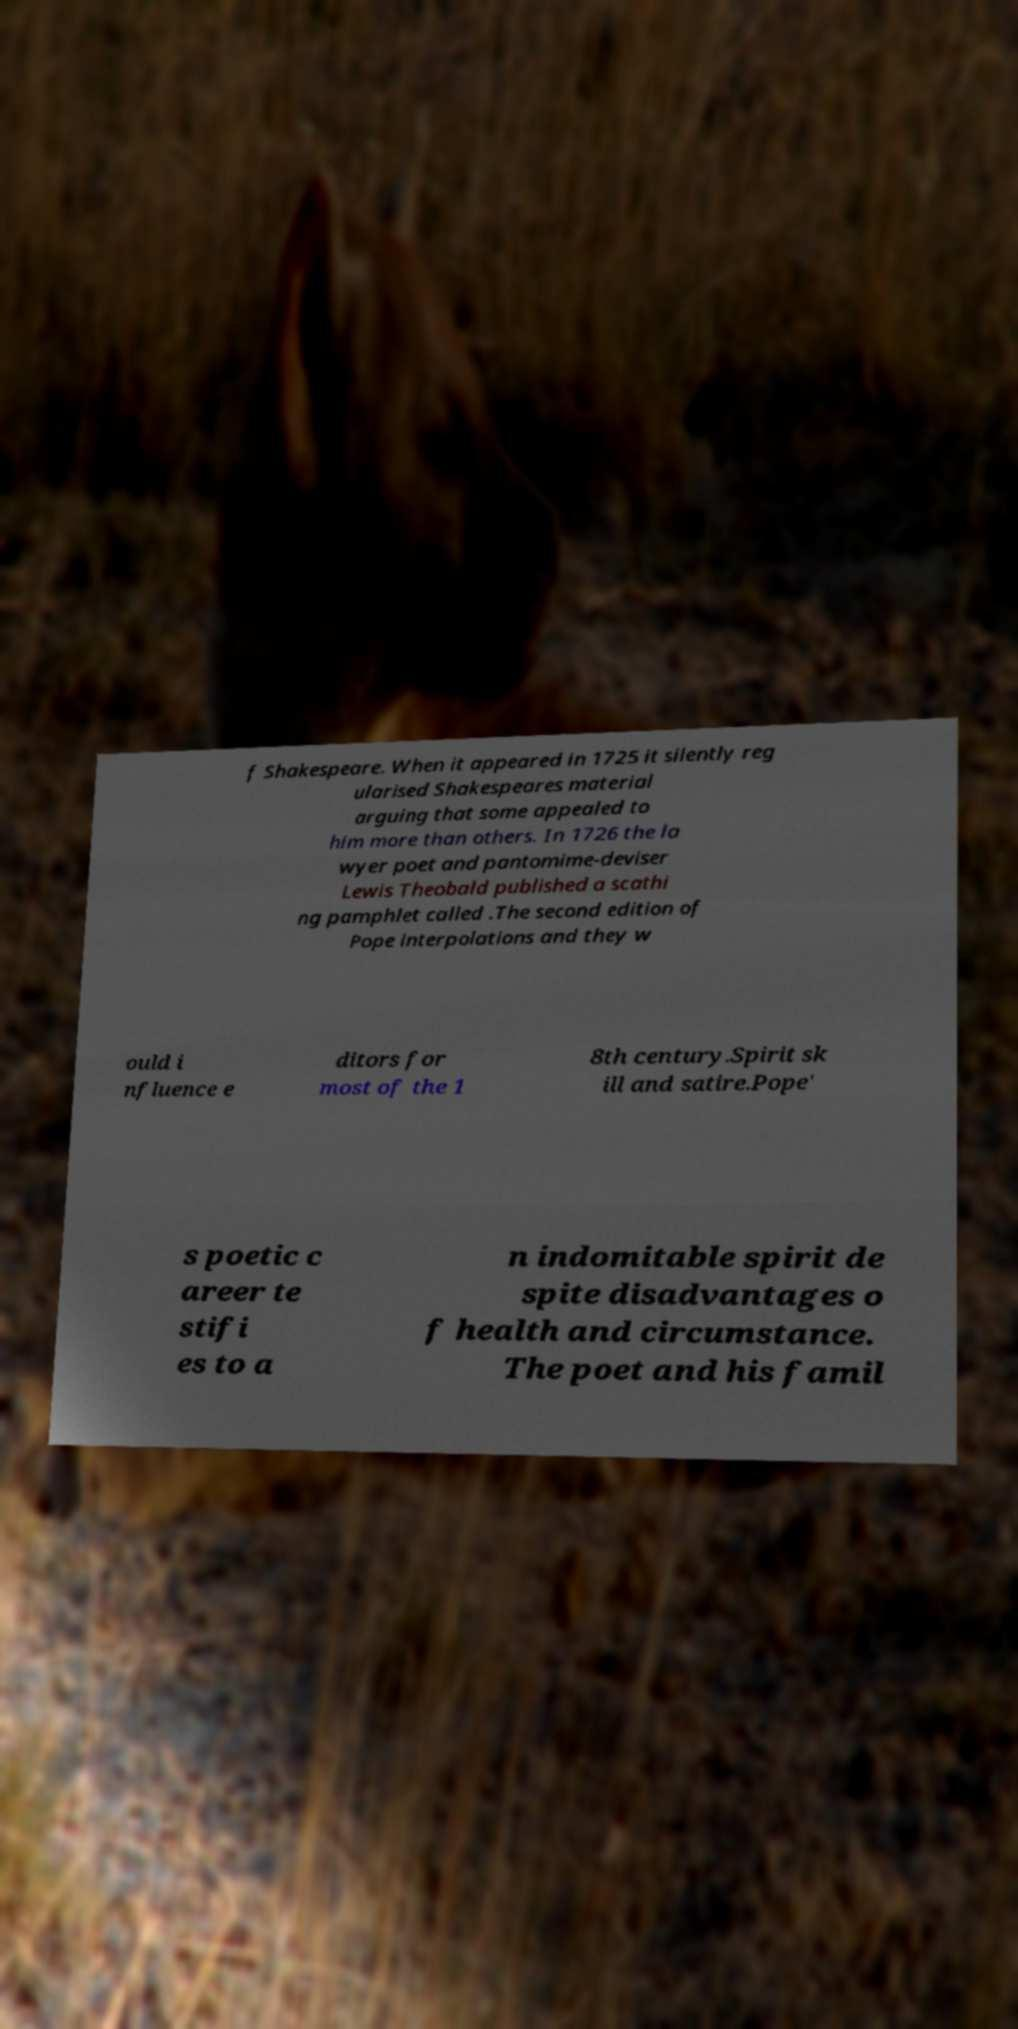What messages or text are displayed in this image? I need them in a readable, typed format. f Shakespeare. When it appeared in 1725 it silently reg ularised Shakespeares material arguing that some appealed to him more than others. In 1726 the la wyer poet and pantomime-deviser Lewis Theobald published a scathi ng pamphlet called .The second edition of Pope interpolations and they w ould i nfluence e ditors for most of the 1 8th century.Spirit sk ill and satire.Pope' s poetic c areer te stifi es to a n indomitable spirit de spite disadvantages o f health and circumstance. The poet and his famil 